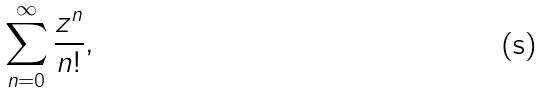Convert formula to latex. <formula><loc_0><loc_0><loc_500><loc_500>\sum _ { n = 0 } ^ { \infty } \frac { z ^ { n } } { n ! } ,</formula> 